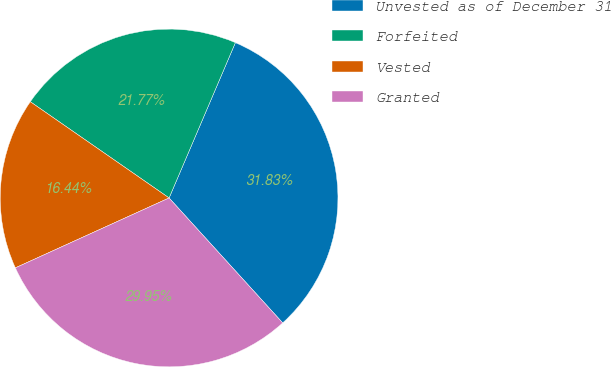<chart> <loc_0><loc_0><loc_500><loc_500><pie_chart><fcel>Unvested as of December 31<fcel>Forfeited<fcel>Vested<fcel>Granted<nl><fcel>31.83%<fcel>21.77%<fcel>16.44%<fcel>29.95%<nl></chart> 